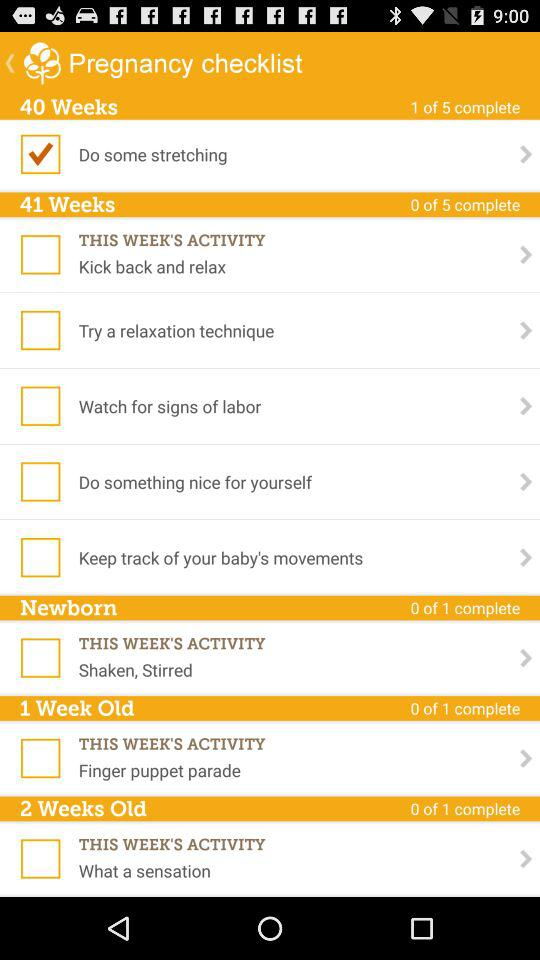What is the status of "Kick back and relax"? The status is "off". 